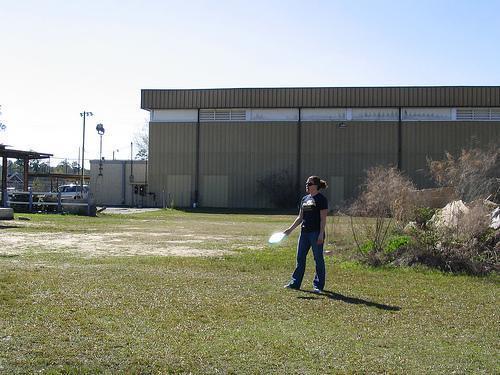How many people are in the photo?
Give a very brief answer. 1. 